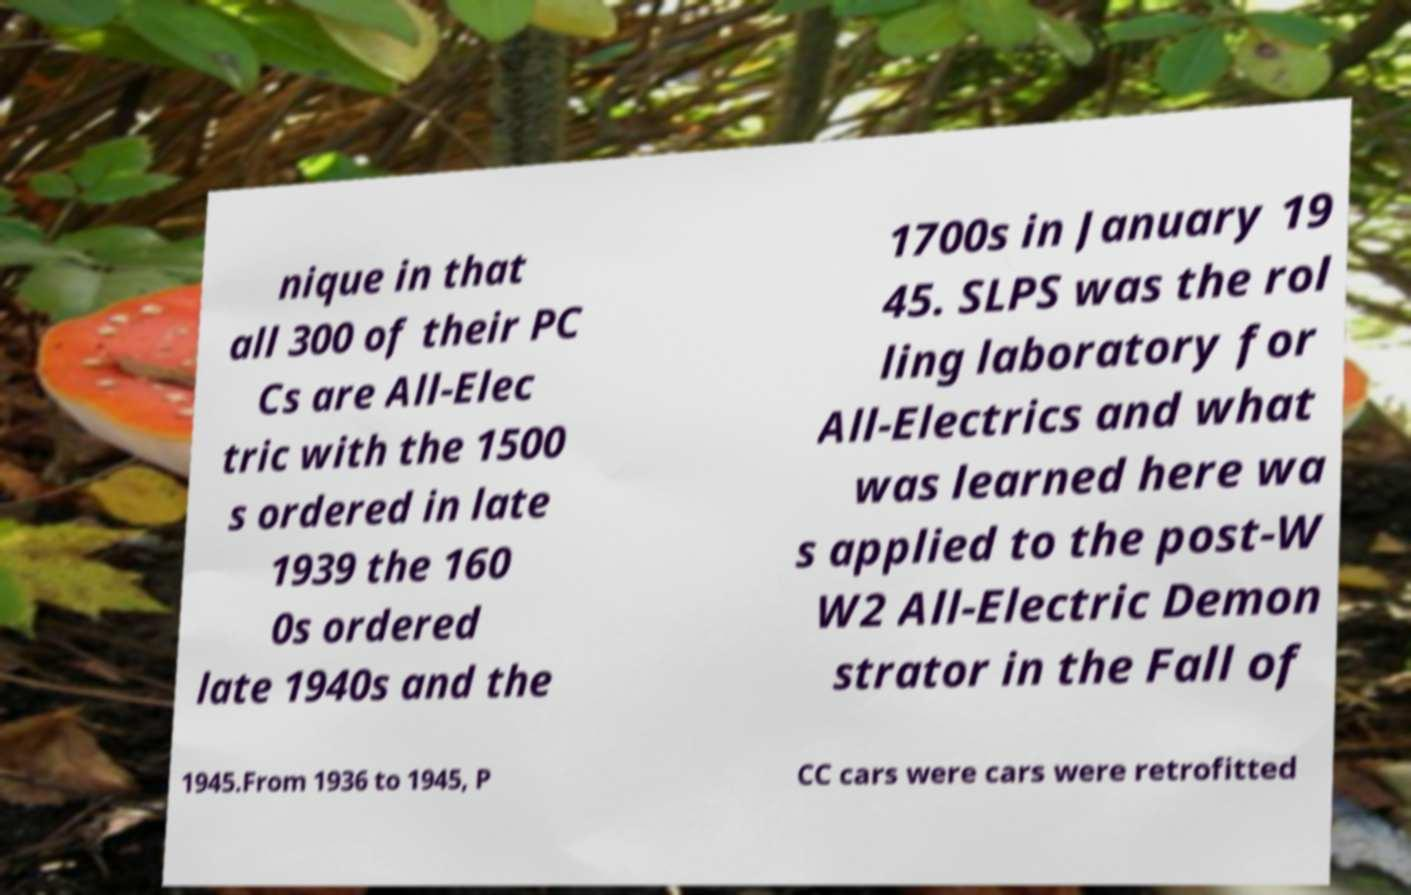For documentation purposes, I need the text within this image transcribed. Could you provide that? nique in that all 300 of their PC Cs are All-Elec tric with the 1500 s ordered in late 1939 the 160 0s ordered late 1940s and the 1700s in January 19 45. SLPS was the rol ling laboratory for All-Electrics and what was learned here wa s applied to the post-W W2 All-Electric Demon strator in the Fall of 1945.From 1936 to 1945, P CC cars were cars were retrofitted 